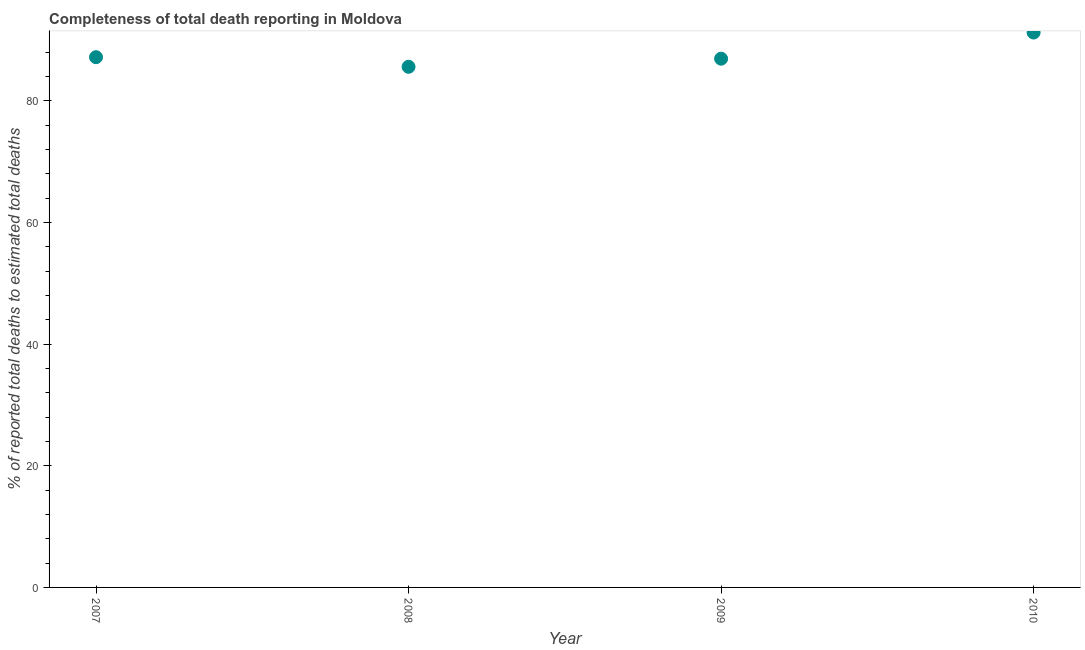What is the completeness of total death reports in 2009?
Your answer should be compact. 86.94. Across all years, what is the maximum completeness of total death reports?
Your answer should be compact. 91.23. Across all years, what is the minimum completeness of total death reports?
Offer a terse response. 85.6. In which year was the completeness of total death reports minimum?
Provide a short and direct response. 2008. What is the sum of the completeness of total death reports?
Give a very brief answer. 350.95. What is the difference between the completeness of total death reports in 2009 and 2010?
Keep it short and to the point. -4.3. What is the average completeness of total death reports per year?
Provide a succinct answer. 87.74. What is the median completeness of total death reports?
Your answer should be very brief. 87.06. In how many years, is the completeness of total death reports greater than 16 %?
Make the answer very short. 4. Do a majority of the years between 2009 and 2008 (inclusive) have completeness of total death reports greater than 40 %?
Make the answer very short. No. What is the ratio of the completeness of total death reports in 2008 to that in 2009?
Your response must be concise. 0.98. Is the completeness of total death reports in 2007 less than that in 2009?
Provide a succinct answer. No. Is the difference between the completeness of total death reports in 2007 and 2008 greater than the difference between any two years?
Keep it short and to the point. No. What is the difference between the highest and the second highest completeness of total death reports?
Offer a very short reply. 4.06. What is the difference between the highest and the lowest completeness of total death reports?
Your answer should be compact. 5.63. How many dotlines are there?
Make the answer very short. 1. What is the difference between two consecutive major ticks on the Y-axis?
Provide a succinct answer. 20. Does the graph contain any zero values?
Give a very brief answer. No. Does the graph contain grids?
Offer a very short reply. No. What is the title of the graph?
Your answer should be compact. Completeness of total death reporting in Moldova. What is the label or title of the X-axis?
Your answer should be very brief. Year. What is the label or title of the Y-axis?
Make the answer very short. % of reported total deaths to estimated total deaths. What is the % of reported total deaths to estimated total deaths in 2007?
Provide a succinct answer. 87.18. What is the % of reported total deaths to estimated total deaths in 2008?
Provide a short and direct response. 85.6. What is the % of reported total deaths to estimated total deaths in 2009?
Keep it short and to the point. 86.94. What is the % of reported total deaths to estimated total deaths in 2010?
Your response must be concise. 91.23. What is the difference between the % of reported total deaths to estimated total deaths in 2007 and 2008?
Your response must be concise. 1.58. What is the difference between the % of reported total deaths to estimated total deaths in 2007 and 2009?
Your answer should be very brief. 0.24. What is the difference between the % of reported total deaths to estimated total deaths in 2007 and 2010?
Your response must be concise. -4.06. What is the difference between the % of reported total deaths to estimated total deaths in 2008 and 2009?
Offer a very short reply. -1.34. What is the difference between the % of reported total deaths to estimated total deaths in 2008 and 2010?
Make the answer very short. -5.63. What is the difference between the % of reported total deaths to estimated total deaths in 2009 and 2010?
Keep it short and to the point. -4.3. What is the ratio of the % of reported total deaths to estimated total deaths in 2007 to that in 2008?
Ensure brevity in your answer.  1.02. What is the ratio of the % of reported total deaths to estimated total deaths in 2007 to that in 2009?
Your answer should be very brief. 1. What is the ratio of the % of reported total deaths to estimated total deaths in 2007 to that in 2010?
Your response must be concise. 0.96. What is the ratio of the % of reported total deaths to estimated total deaths in 2008 to that in 2009?
Your response must be concise. 0.98. What is the ratio of the % of reported total deaths to estimated total deaths in 2008 to that in 2010?
Offer a terse response. 0.94. What is the ratio of the % of reported total deaths to estimated total deaths in 2009 to that in 2010?
Your answer should be very brief. 0.95. 